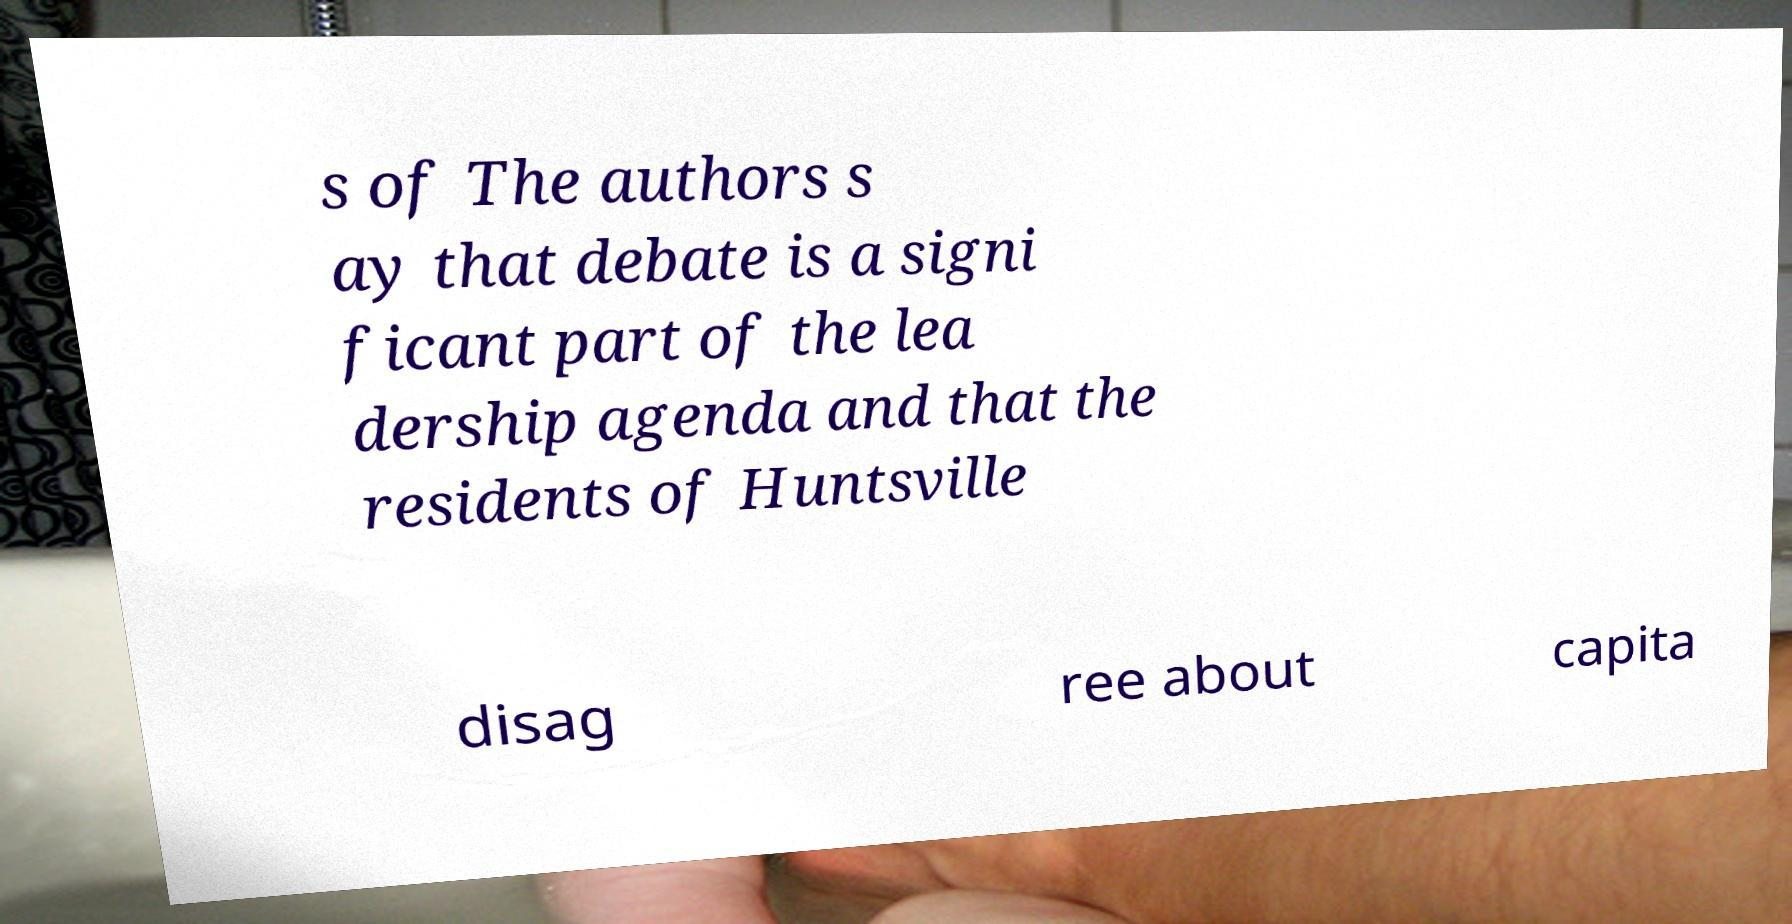Could you assist in decoding the text presented in this image and type it out clearly? s of The authors s ay that debate is a signi ficant part of the lea dership agenda and that the residents of Huntsville disag ree about capita 